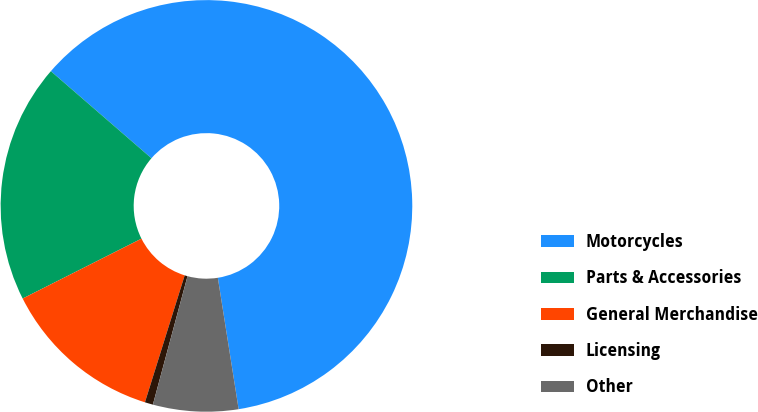<chart> <loc_0><loc_0><loc_500><loc_500><pie_chart><fcel>Motorcycles<fcel>Parts & Accessories<fcel>General Merchandise<fcel>Licensing<fcel>Other<nl><fcel>61.15%<fcel>18.79%<fcel>12.74%<fcel>0.64%<fcel>6.69%<nl></chart> 